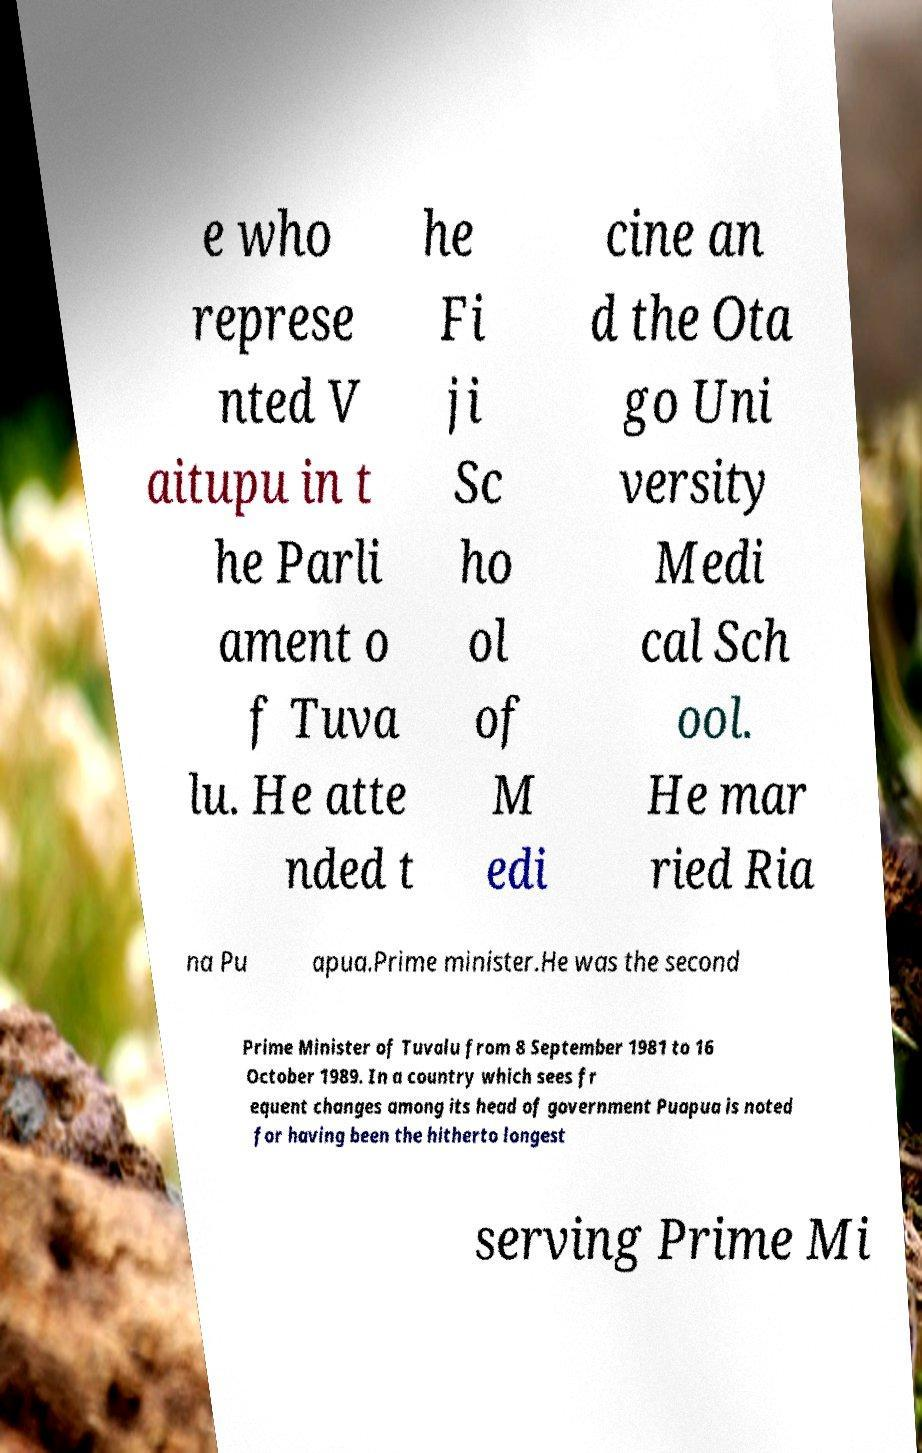Can you read and provide the text displayed in the image?This photo seems to have some interesting text. Can you extract and type it out for me? e who represe nted V aitupu in t he Parli ament o f Tuva lu. He atte nded t he Fi ji Sc ho ol of M edi cine an d the Ota go Uni versity Medi cal Sch ool. He mar ried Ria na Pu apua.Prime minister.He was the second Prime Minister of Tuvalu from 8 September 1981 to 16 October 1989. In a country which sees fr equent changes among its head of government Puapua is noted for having been the hitherto longest serving Prime Mi 